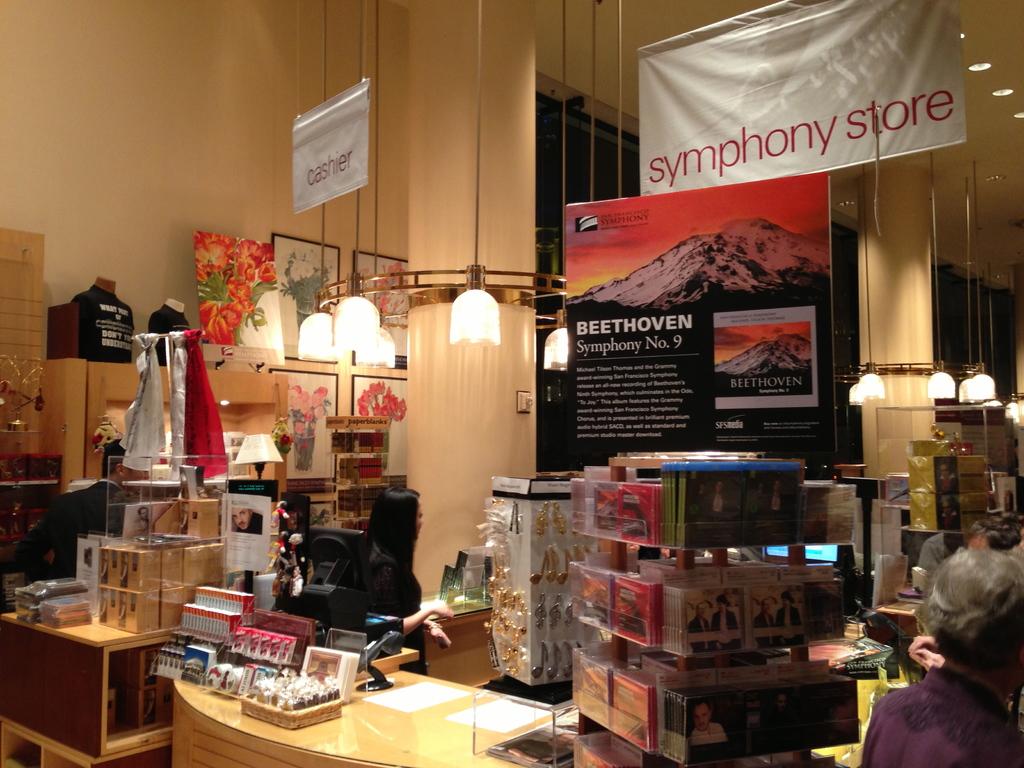Who composed symphony no. 9?
Keep it short and to the point. Beethoven. 